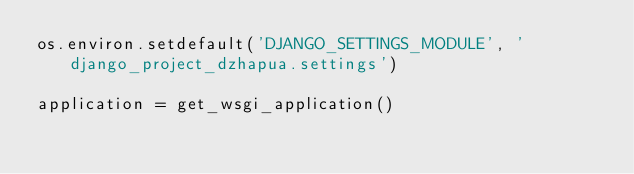<code> <loc_0><loc_0><loc_500><loc_500><_Python_>os.environ.setdefault('DJANGO_SETTINGS_MODULE', 'django_project_dzhapua.settings')

application = get_wsgi_application()
</code> 